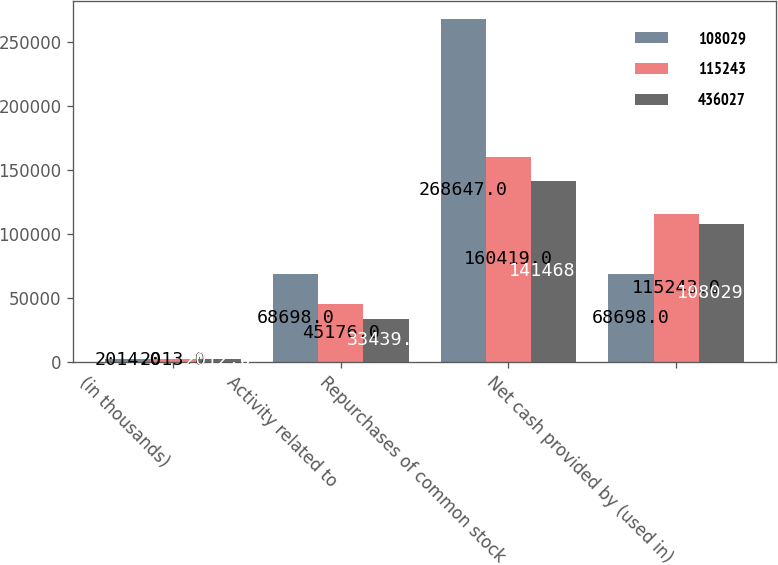Convert chart to OTSL. <chart><loc_0><loc_0><loc_500><loc_500><stacked_bar_chart><ecel><fcel>(in thousands)<fcel>Activity related to<fcel>Repurchases of common stock<fcel>Net cash provided by (used in)<nl><fcel>108029<fcel>2014<fcel>68698<fcel>268647<fcel>68698<nl><fcel>115243<fcel>2013<fcel>45176<fcel>160419<fcel>115243<nl><fcel>436027<fcel>2012<fcel>33439<fcel>141468<fcel>108029<nl></chart> 